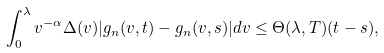<formula> <loc_0><loc_0><loc_500><loc_500>\int _ { 0 } ^ { \lambda } v ^ { - \alpha } & \Delta ( v ) | g _ { n } ( v , t ) - g _ { n } ( v , s ) | d v \leq \Theta ( \lambda , T ) ( t - s ) ,</formula> 